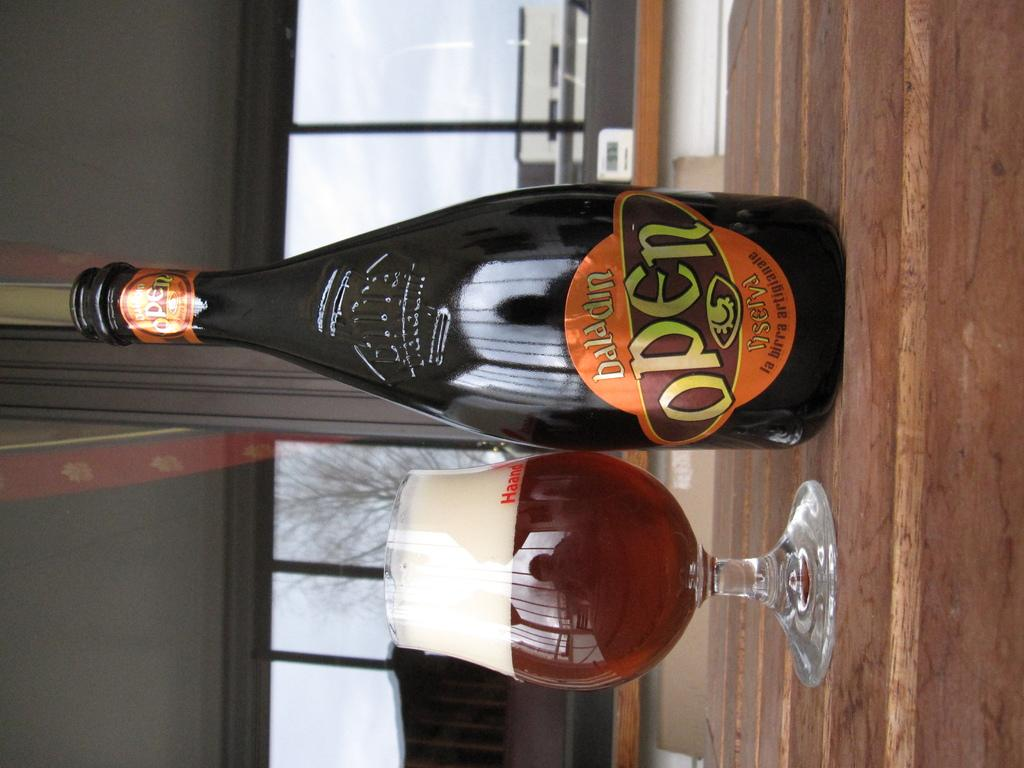What is in the bottle that is visible in the image? There is a bottle with a label in the image. What is in the glass that is visible in the image? There is a glass with liquid in the image. What can be seen in the background of the image? There are glass windows in the background of the image. What is visible through the glass windows in the image? A tree is visible through the glass windows. How many dogs are wearing gloves in the image? There are no dogs or gloves present in the image. What type of bit is being used to interact with the tree in the image? There is no bit present in the image, and the tree is visible through the glass windows, not being interacted with directly. 